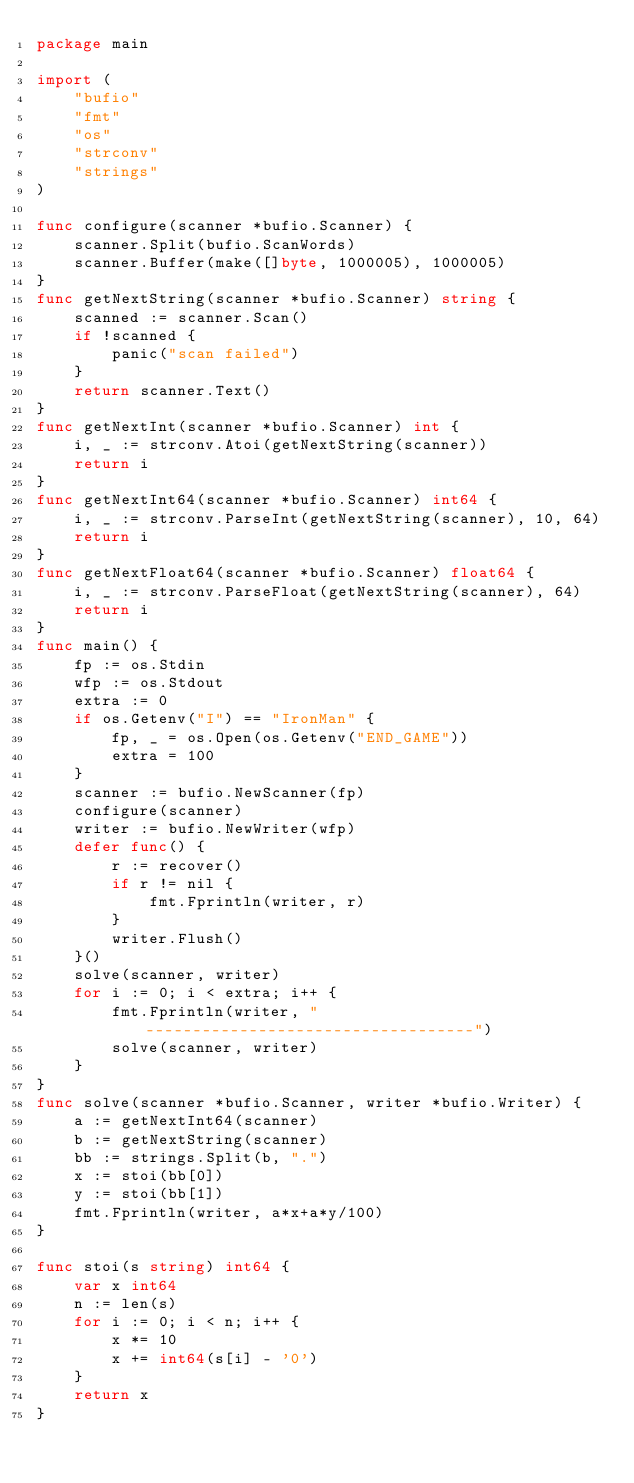Convert code to text. <code><loc_0><loc_0><loc_500><loc_500><_Go_>package main

import (
	"bufio"
	"fmt"
	"os"
	"strconv"
	"strings"
)

func configure(scanner *bufio.Scanner) {
	scanner.Split(bufio.ScanWords)
	scanner.Buffer(make([]byte, 1000005), 1000005)
}
func getNextString(scanner *bufio.Scanner) string {
	scanned := scanner.Scan()
	if !scanned {
		panic("scan failed")
	}
	return scanner.Text()
}
func getNextInt(scanner *bufio.Scanner) int {
	i, _ := strconv.Atoi(getNextString(scanner))
	return i
}
func getNextInt64(scanner *bufio.Scanner) int64 {
	i, _ := strconv.ParseInt(getNextString(scanner), 10, 64)
	return i
}
func getNextFloat64(scanner *bufio.Scanner) float64 {
	i, _ := strconv.ParseFloat(getNextString(scanner), 64)
	return i
}
func main() {
	fp := os.Stdin
	wfp := os.Stdout
	extra := 0
	if os.Getenv("I") == "IronMan" {
		fp, _ = os.Open(os.Getenv("END_GAME"))
		extra = 100
	}
	scanner := bufio.NewScanner(fp)
	configure(scanner)
	writer := bufio.NewWriter(wfp)
	defer func() {
		r := recover()
		if r != nil {
			fmt.Fprintln(writer, r)
		}
		writer.Flush()
	}()
	solve(scanner, writer)
	for i := 0; i < extra; i++ {
		fmt.Fprintln(writer, "-----------------------------------")
		solve(scanner, writer)
	}
}
func solve(scanner *bufio.Scanner, writer *bufio.Writer) {
	a := getNextInt64(scanner)
	b := getNextString(scanner)
	bb := strings.Split(b, ".")
	x := stoi(bb[0])
	y := stoi(bb[1])
	fmt.Fprintln(writer, a*x+a*y/100)
}

func stoi(s string) int64 {
	var x int64
	n := len(s)
	for i := 0; i < n; i++ {
		x *= 10
		x += int64(s[i] - '0')
	}
	return x
}
</code> 